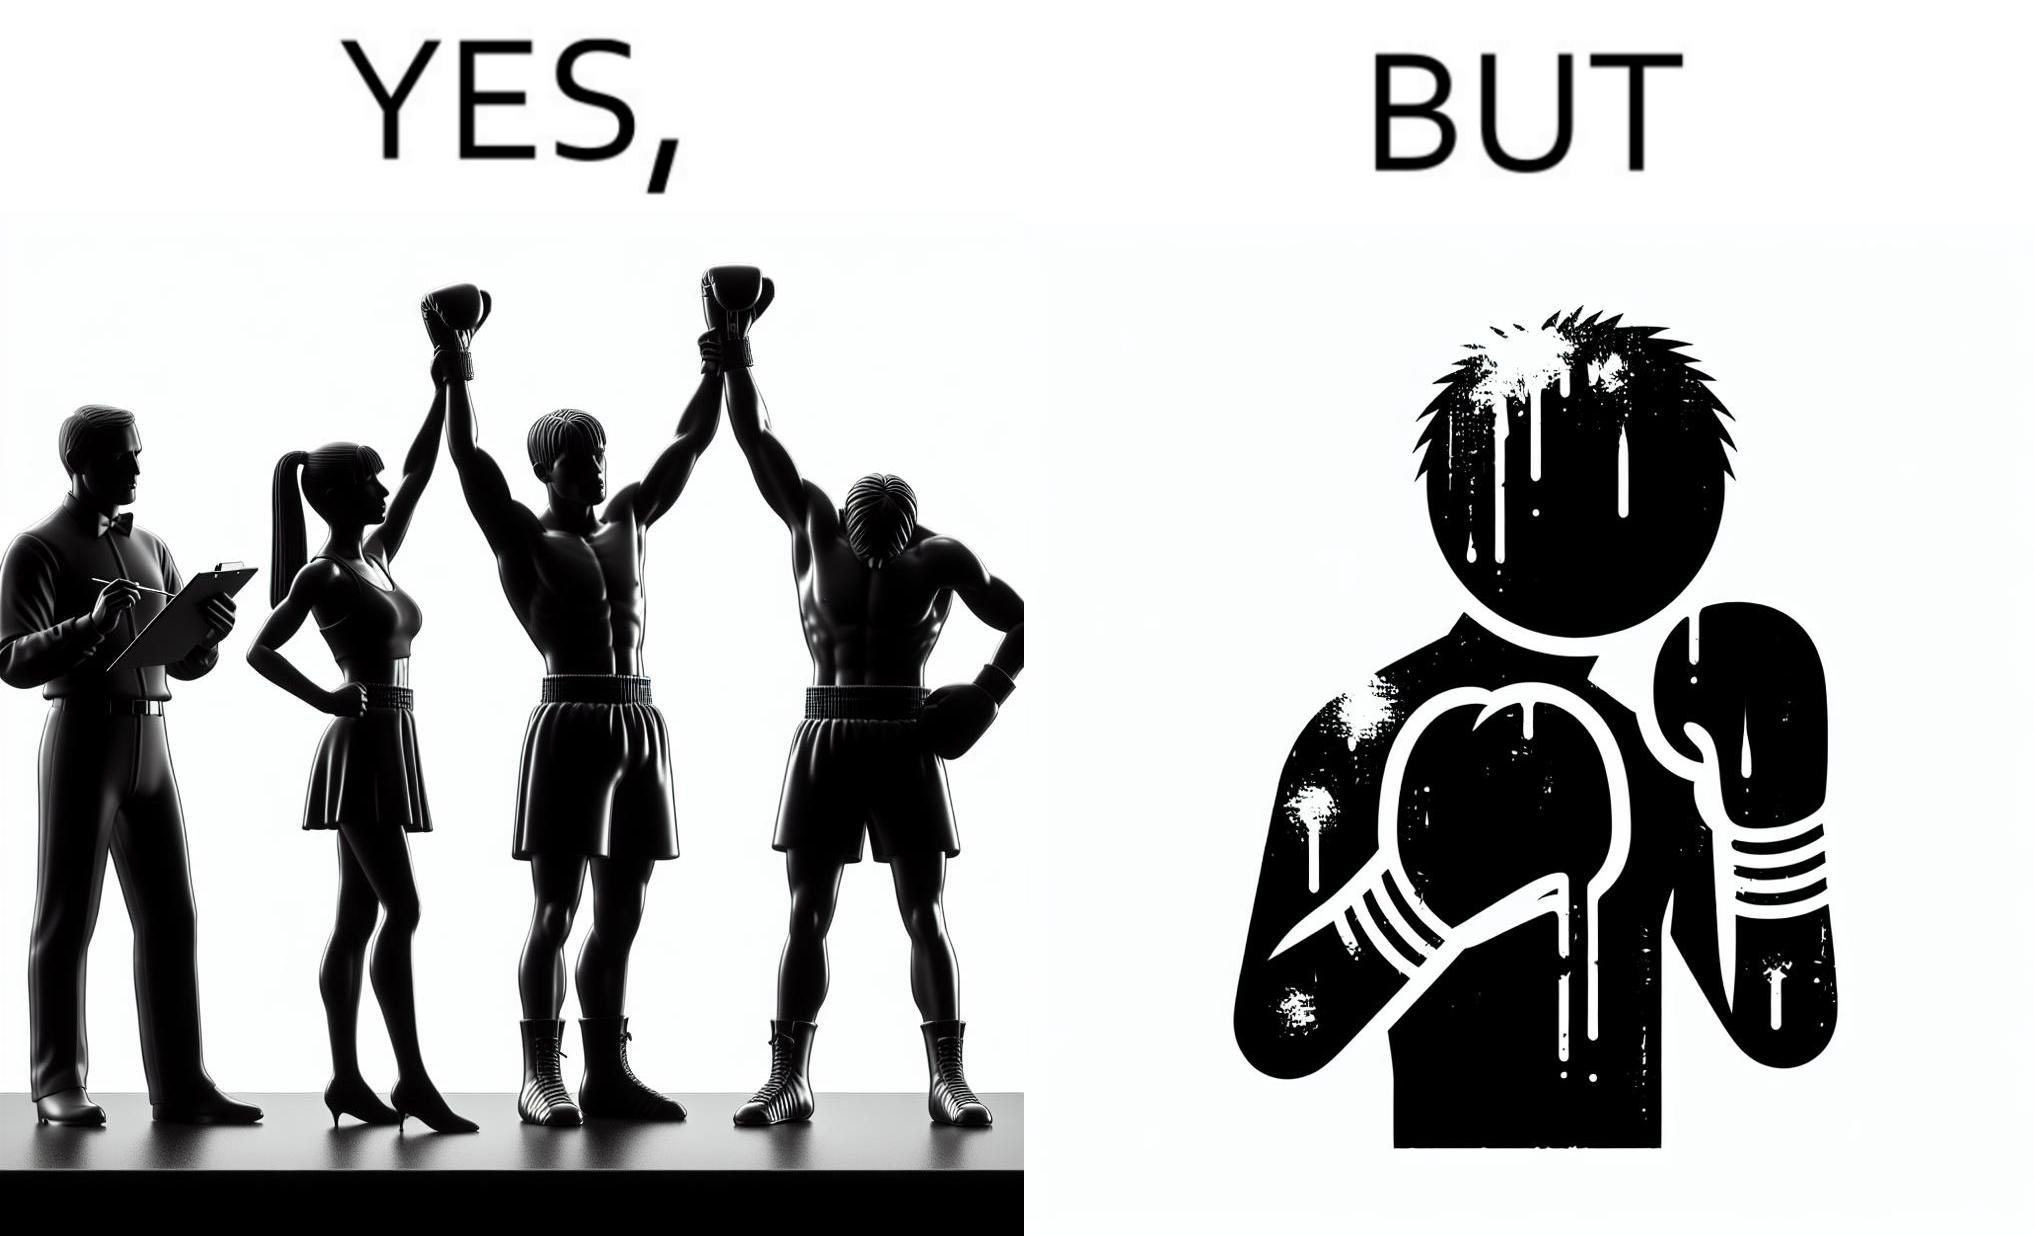Is this image satirical or non-satirical? Yes, this image is satirical. 